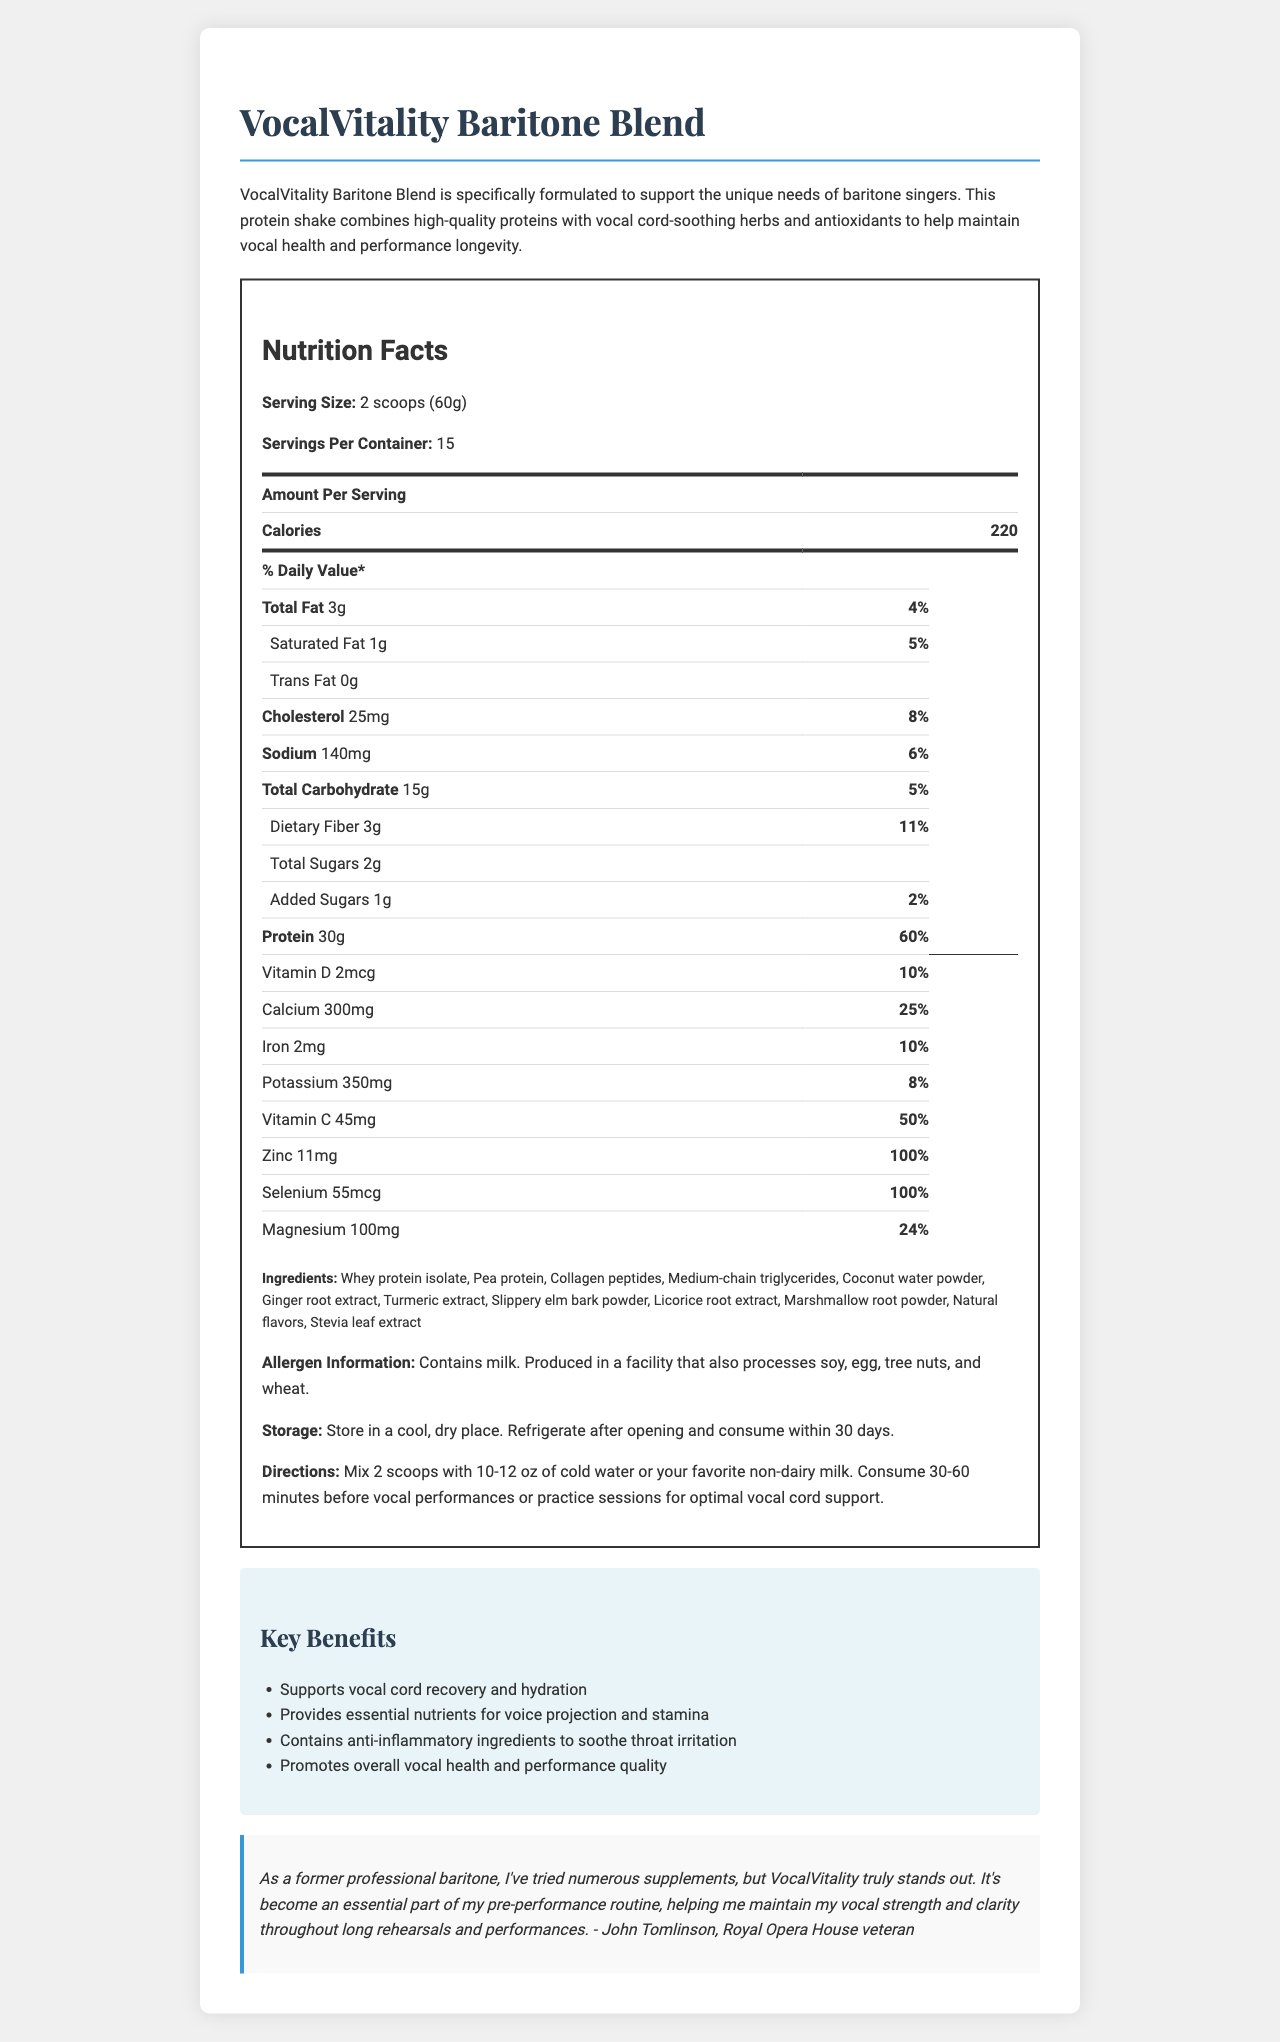what is the serving size for the VocalVitality Baritone Blend? The serving size is mentioned explicitly in the Nutrition Facts section under "Serving Size," which states "2 scoops (60g)."
Answer: 2 scoops (60g) how many servings are in one container of VocalVitality Baritone Blend? The number of servings per container is stated as "Servings Per Container: 15."
Answer: 15 how many calories are there per serving? The calories per serving are found in the Nutrition Facts section, where it indicates "Calories 220."
Answer: 220 how much protein does each serving contain? The amount of protein per serving is stated in the Nutrition Facts section as "Protein 30g."
Answer: 30g what are the storage instructions for this product? The storage instructions are provided towards the end of the Nutrition Facts label.
Answer: Store in a cool, dry place. Refrigerate after opening and consume within 30 days. which ingredient is not listed in the ingredients section? A. Whey protein isolate B. Honey C. Coconut water powder Honey is not listed among the ingredients; the document lists "Whey protein isolate" and "Coconut water powder," but not honey.
Answer: B. Honey what is the percentage daily value of Iron in one serving? A. 24% B. 10% C. 50% D. 25% The daily value percentage for Iron is given as "10%" in the Nutrition Facts section.
Answer: B. 10% is there any trans fat in this product? The Nutrition Facts state "Trans Fat 0g," indicating there is no trans fat.
Answer: No summarize the main purpose of VocalVitality Baritone Blend. The blend aims to support vocal cord recovery, provide essential nutrients, soothe throat irritation, and promote overall vocal health.
Answer: VocalVitality Baritone Blend is a protein shake designed to support vocal cord health for baritone singers, combining high-quality proteins with herbs and antioxidants to maintain vocal health and performance. what are the potential allergens in this product? The allergen information is provided, mentioning milk and possible cross-contamination with soy, egg, tree nuts, and wheat.
Answer: Contains milk. Produced in a facility that also processes soy, egg, tree nuts, and wheat. how much sodium does one serving contain? The Nutrition Facts list "Sodium 140mg" under the relevant section.
Answer: 140mg which key benefit is not mentioned? A. Supports vocal cord recovery B. Increases muscle mass C. Provides essential nutrients D. Promotes overall vocal health Increasing muscle mass is not mentioned among the key benefits, which focus on vocal cord recovery, providing nutrients, soothing irritation, and promoting vocal health.
Answer: B. Increases muscle mass what is the recommended time to consume this protein shake for optimal vocal cord support? The directions for use state to consume the shake 30-60 minutes before vocal performances or practice sessions for optimal support.
Answer: 30-60 minutes before vocal performances or practice sessions who has provided a testimonial for this product? The testimonial is attributed to John Tomlinson, a veteran of the Royal Opera House.
Answer: John Tomlinson, Royal Opera House veteran is this product gluten-free? The document does not specify anything about gluten-free status, only mentioning potential allergens like soy, egg, tree nuts, and wheat. Therefore, we cannot determine if it is gluten-free based on the provided information.
Answer: Not enough information 